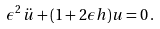<formula> <loc_0><loc_0><loc_500><loc_500>\epsilon ^ { 2 } \, \ddot { u } + ( 1 + 2 \epsilon h ) u = 0 \, .</formula> 